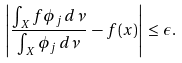Convert formula to latex. <formula><loc_0><loc_0><loc_500><loc_500>\left | \frac { \int _ { X } f \phi _ { j } \, d \nu } { \int _ { X } \phi _ { j } \, d \nu } \, - \, f ( x ) \right | \, \leq \, \epsilon .</formula> 